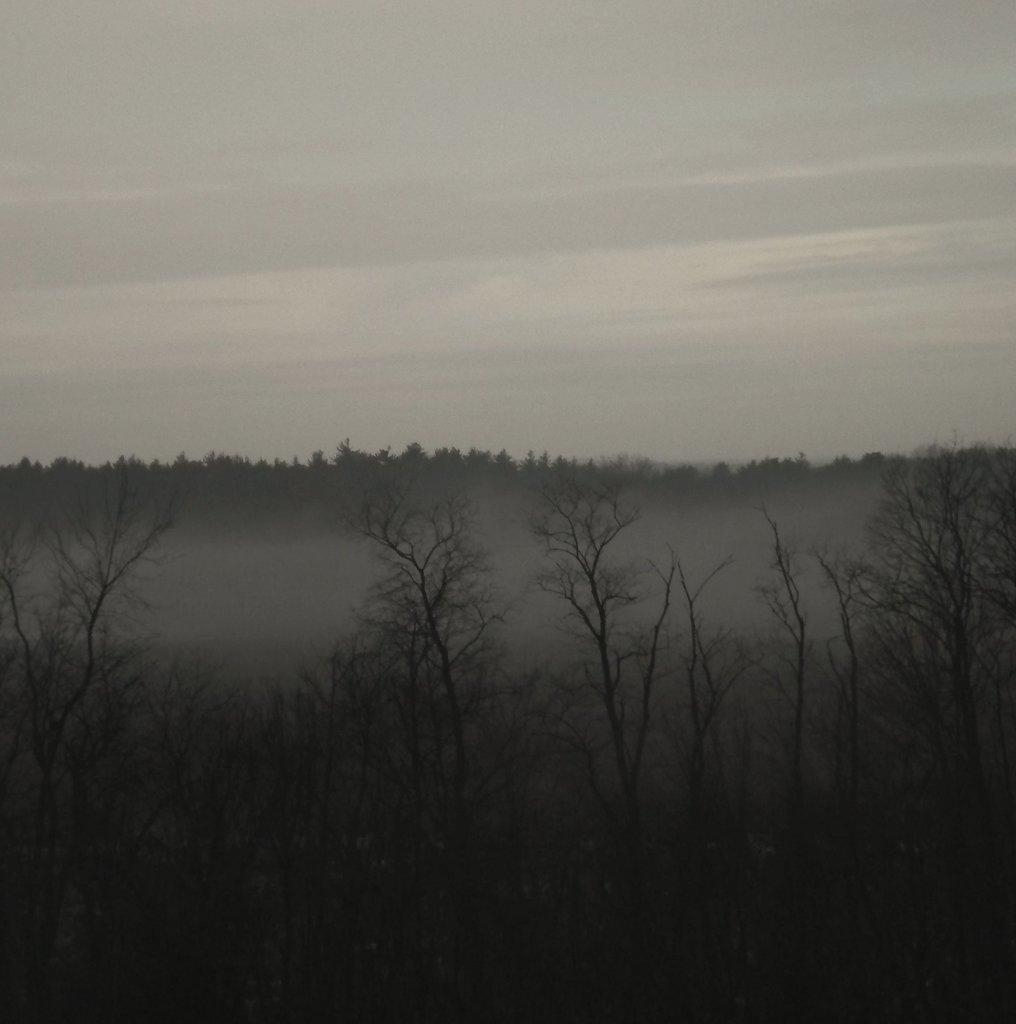What type of vegetation can be seen in the image? There are trees in the image. What part of the natural environment is visible in the image? The sky is visible in the background of the image. How does the tramp help the trees grow in the image? There is no tramp present in the image, and therefore no such assistance can be observed. 